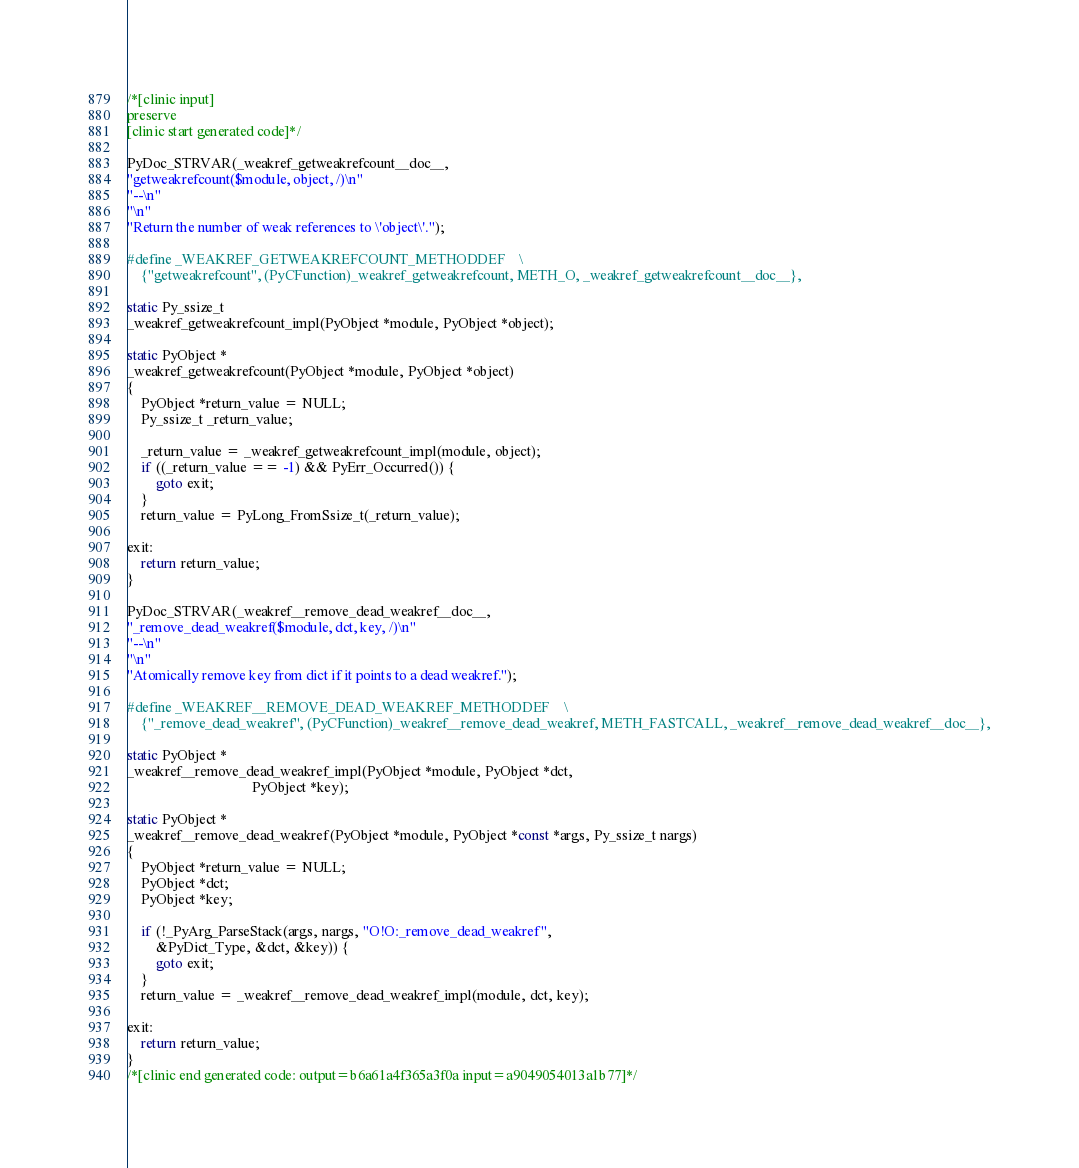Convert code to text. <code><loc_0><loc_0><loc_500><loc_500><_C_>/*[clinic input]
preserve
[clinic start generated code]*/

PyDoc_STRVAR(_weakref_getweakrefcount__doc__,
"getweakrefcount($module, object, /)\n"
"--\n"
"\n"
"Return the number of weak references to \'object\'.");

#define _WEAKREF_GETWEAKREFCOUNT_METHODDEF    \
    {"getweakrefcount", (PyCFunction)_weakref_getweakrefcount, METH_O, _weakref_getweakrefcount__doc__},

static Py_ssize_t
_weakref_getweakrefcount_impl(PyObject *module, PyObject *object);

static PyObject *
_weakref_getweakrefcount(PyObject *module, PyObject *object)
{
    PyObject *return_value = NULL;
    Py_ssize_t _return_value;

    _return_value = _weakref_getweakrefcount_impl(module, object);
    if ((_return_value == -1) && PyErr_Occurred()) {
        goto exit;
    }
    return_value = PyLong_FromSsize_t(_return_value);

exit:
    return return_value;
}

PyDoc_STRVAR(_weakref__remove_dead_weakref__doc__,
"_remove_dead_weakref($module, dct, key, /)\n"
"--\n"
"\n"
"Atomically remove key from dict if it points to a dead weakref.");

#define _WEAKREF__REMOVE_DEAD_WEAKREF_METHODDEF    \
    {"_remove_dead_weakref", (PyCFunction)_weakref__remove_dead_weakref, METH_FASTCALL, _weakref__remove_dead_weakref__doc__},

static PyObject *
_weakref__remove_dead_weakref_impl(PyObject *module, PyObject *dct,
                                   PyObject *key);

static PyObject *
_weakref__remove_dead_weakref(PyObject *module, PyObject *const *args, Py_ssize_t nargs)
{
    PyObject *return_value = NULL;
    PyObject *dct;
    PyObject *key;

    if (!_PyArg_ParseStack(args, nargs, "O!O:_remove_dead_weakref",
        &PyDict_Type, &dct, &key)) {
        goto exit;
    }
    return_value = _weakref__remove_dead_weakref_impl(module, dct, key);

exit:
    return return_value;
}
/*[clinic end generated code: output=b6a61a4f365a3f0a input=a9049054013a1b77]*/
</code> 